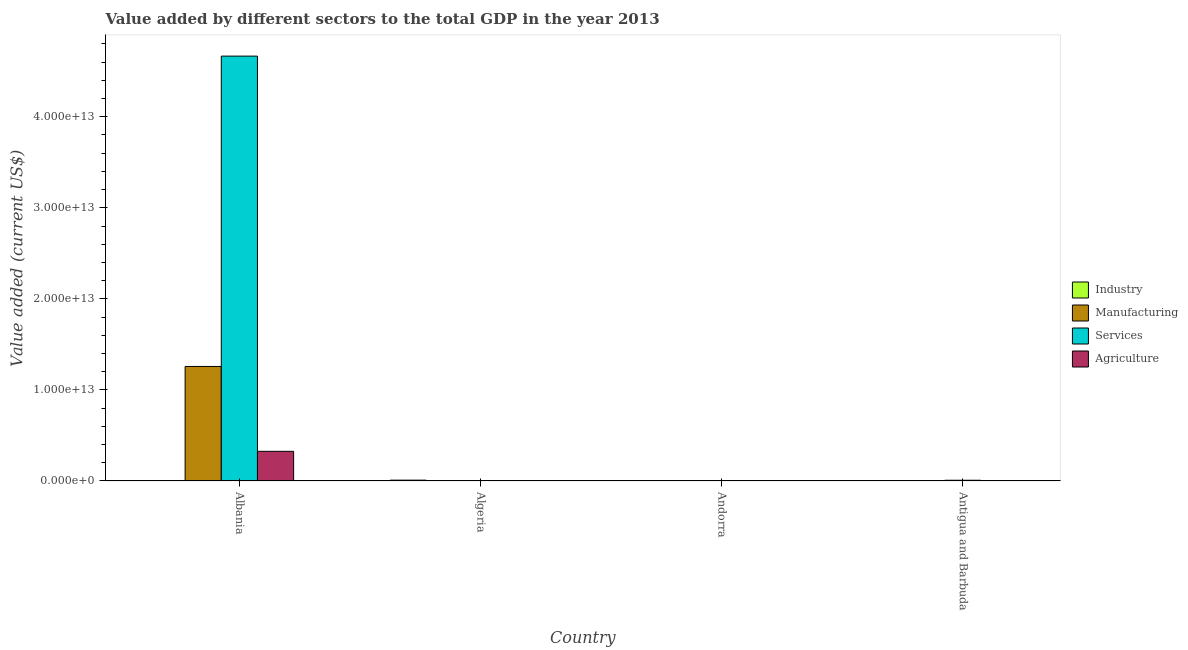How many different coloured bars are there?
Offer a very short reply. 4. Are the number of bars on each tick of the X-axis equal?
Give a very brief answer. Yes. How many bars are there on the 4th tick from the left?
Your answer should be very brief. 4. How many bars are there on the 3rd tick from the right?
Make the answer very short. 4. What is the label of the 4th group of bars from the left?
Offer a terse response. Antigua and Barbuda. In how many cases, is the number of bars for a given country not equal to the number of legend labels?
Keep it short and to the point. 0. What is the value added by services sector in Andorra?
Your answer should be compact. 5.70e+09. Across all countries, what is the maximum value added by agricultural sector?
Your answer should be compact. 3.26e+12. Across all countries, what is the minimum value added by services sector?
Provide a short and direct response. 5.70e+09. In which country was the value added by industrial sector maximum?
Ensure brevity in your answer.  Algeria. In which country was the value added by manufacturing sector minimum?
Give a very brief answer. Antigua and Barbuda. What is the total value added by agricultural sector in the graph?
Provide a succinct answer. 3.29e+12. What is the difference between the value added by agricultural sector in Algeria and that in Andorra?
Provide a short and direct response. 2.18e+09. What is the difference between the value added by industrial sector in Algeria and the value added by manufacturing sector in Andorra?
Ensure brevity in your answer.  9.21e+1. What is the average value added by agricultural sector per country?
Offer a very short reply. 8.22e+11. What is the difference between the value added by services sector and value added by industrial sector in Antigua and Barbuda?
Make the answer very short. 8.05e+1. What is the ratio of the value added by industrial sector in Algeria to that in Antigua and Barbuda?
Offer a terse response. 492.26. What is the difference between the highest and the second highest value added by manufacturing sector?
Provide a short and direct response. 1.26e+13. What is the difference between the highest and the lowest value added by industrial sector?
Make the answer very short. 9.26e+1. Is the sum of the value added by agricultural sector in Andorra and Antigua and Barbuda greater than the maximum value added by manufacturing sector across all countries?
Your answer should be compact. No. Is it the case that in every country, the sum of the value added by agricultural sector and value added by manufacturing sector is greater than the sum of value added by industrial sector and value added by services sector?
Offer a very short reply. No. What does the 4th bar from the left in Andorra represents?
Offer a very short reply. Agriculture. What does the 4th bar from the right in Algeria represents?
Ensure brevity in your answer.  Industry. Is it the case that in every country, the sum of the value added by industrial sector and value added by manufacturing sector is greater than the value added by services sector?
Ensure brevity in your answer.  No. How many countries are there in the graph?
Your answer should be very brief. 4. What is the difference between two consecutive major ticks on the Y-axis?
Offer a very short reply. 1.00e+13. Are the values on the major ticks of Y-axis written in scientific E-notation?
Keep it short and to the point. Yes. Does the graph contain grids?
Give a very brief answer. No. How many legend labels are there?
Keep it short and to the point. 4. What is the title of the graph?
Give a very brief answer. Value added by different sectors to the total GDP in the year 2013. What is the label or title of the X-axis?
Ensure brevity in your answer.  Country. What is the label or title of the Y-axis?
Your answer should be very brief. Value added (current US$). What is the Value added (current US$) in Industry in Albania?
Offer a very short reply. 2.94e+09. What is the Value added (current US$) in Manufacturing in Albania?
Your response must be concise. 1.26e+13. What is the Value added (current US$) in Services in Albania?
Make the answer very short. 4.67e+13. What is the Value added (current US$) in Agriculture in Albania?
Make the answer very short. 3.26e+12. What is the Value added (current US$) in Industry in Algeria?
Your answer should be compact. 9.27e+1. What is the Value added (current US$) of Manufacturing in Algeria?
Offer a terse response. 2.36e+09. What is the Value added (current US$) of Services in Algeria?
Your answer should be very brief. 1.08e+1. What is the Value added (current US$) of Agriculture in Algeria?
Provide a short and direct response. 4.69e+09. What is the Value added (current US$) of Industry in Andorra?
Your answer should be compact. 3.39e+08. What is the Value added (current US$) of Manufacturing in Andorra?
Your answer should be compact. 6.22e+08. What is the Value added (current US$) in Services in Andorra?
Make the answer very short. 5.70e+09. What is the Value added (current US$) in Agriculture in Andorra?
Your answer should be compact. 2.51e+09. What is the Value added (current US$) of Industry in Antigua and Barbuda?
Give a very brief answer. 1.88e+08. What is the Value added (current US$) of Manufacturing in Antigua and Barbuda?
Offer a very short reply. 1.03e+08. What is the Value added (current US$) of Services in Antigua and Barbuda?
Provide a short and direct response. 8.06e+1. What is the Value added (current US$) in Agriculture in Antigua and Barbuda?
Provide a short and direct response. 2.07e+1. Across all countries, what is the maximum Value added (current US$) in Industry?
Keep it short and to the point. 9.27e+1. Across all countries, what is the maximum Value added (current US$) in Manufacturing?
Your response must be concise. 1.26e+13. Across all countries, what is the maximum Value added (current US$) in Services?
Provide a succinct answer. 4.67e+13. Across all countries, what is the maximum Value added (current US$) in Agriculture?
Your answer should be very brief. 3.26e+12. Across all countries, what is the minimum Value added (current US$) of Industry?
Ensure brevity in your answer.  1.88e+08. Across all countries, what is the minimum Value added (current US$) of Manufacturing?
Give a very brief answer. 1.03e+08. Across all countries, what is the minimum Value added (current US$) in Services?
Offer a terse response. 5.70e+09. Across all countries, what is the minimum Value added (current US$) of Agriculture?
Your answer should be very brief. 2.51e+09. What is the total Value added (current US$) of Industry in the graph?
Keep it short and to the point. 9.62e+1. What is the total Value added (current US$) of Manufacturing in the graph?
Provide a short and direct response. 1.26e+13. What is the total Value added (current US$) of Services in the graph?
Your answer should be very brief. 4.68e+13. What is the total Value added (current US$) of Agriculture in the graph?
Your answer should be compact. 3.29e+12. What is the difference between the Value added (current US$) in Industry in Albania and that in Algeria?
Provide a short and direct response. -8.98e+1. What is the difference between the Value added (current US$) in Manufacturing in Albania and that in Algeria?
Your response must be concise. 1.26e+13. What is the difference between the Value added (current US$) in Services in Albania and that in Algeria?
Offer a terse response. 4.66e+13. What is the difference between the Value added (current US$) of Agriculture in Albania and that in Algeria?
Keep it short and to the point. 3.25e+12. What is the difference between the Value added (current US$) of Industry in Albania and that in Andorra?
Give a very brief answer. 2.60e+09. What is the difference between the Value added (current US$) in Manufacturing in Albania and that in Andorra?
Offer a terse response. 1.26e+13. What is the difference between the Value added (current US$) of Services in Albania and that in Andorra?
Your answer should be very brief. 4.67e+13. What is the difference between the Value added (current US$) of Agriculture in Albania and that in Andorra?
Give a very brief answer. 3.26e+12. What is the difference between the Value added (current US$) of Industry in Albania and that in Antigua and Barbuda?
Make the answer very short. 2.75e+09. What is the difference between the Value added (current US$) in Manufacturing in Albania and that in Antigua and Barbuda?
Make the answer very short. 1.26e+13. What is the difference between the Value added (current US$) of Services in Albania and that in Antigua and Barbuda?
Keep it short and to the point. 4.66e+13. What is the difference between the Value added (current US$) of Agriculture in Albania and that in Antigua and Barbuda?
Give a very brief answer. 3.24e+12. What is the difference between the Value added (current US$) of Industry in Algeria and that in Andorra?
Your response must be concise. 9.24e+1. What is the difference between the Value added (current US$) of Manufacturing in Algeria and that in Andorra?
Provide a succinct answer. 1.74e+09. What is the difference between the Value added (current US$) of Services in Algeria and that in Andorra?
Offer a terse response. 5.09e+09. What is the difference between the Value added (current US$) of Agriculture in Algeria and that in Andorra?
Ensure brevity in your answer.  2.18e+09. What is the difference between the Value added (current US$) in Industry in Algeria and that in Antigua and Barbuda?
Provide a short and direct response. 9.26e+1. What is the difference between the Value added (current US$) in Manufacturing in Algeria and that in Antigua and Barbuda?
Your answer should be compact. 2.26e+09. What is the difference between the Value added (current US$) of Services in Algeria and that in Antigua and Barbuda?
Keep it short and to the point. -6.99e+1. What is the difference between the Value added (current US$) in Agriculture in Algeria and that in Antigua and Barbuda?
Offer a very short reply. -1.60e+1. What is the difference between the Value added (current US$) of Industry in Andorra and that in Antigua and Barbuda?
Keep it short and to the point. 1.50e+08. What is the difference between the Value added (current US$) in Manufacturing in Andorra and that in Antigua and Barbuda?
Give a very brief answer. 5.19e+08. What is the difference between the Value added (current US$) of Services in Andorra and that in Antigua and Barbuda?
Give a very brief answer. -7.49e+1. What is the difference between the Value added (current US$) in Agriculture in Andorra and that in Antigua and Barbuda?
Provide a succinct answer. -1.82e+1. What is the difference between the Value added (current US$) of Industry in Albania and the Value added (current US$) of Manufacturing in Algeria?
Make the answer very short. 5.79e+08. What is the difference between the Value added (current US$) of Industry in Albania and the Value added (current US$) of Services in Algeria?
Provide a succinct answer. -7.85e+09. What is the difference between the Value added (current US$) of Industry in Albania and the Value added (current US$) of Agriculture in Algeria?
Your answer should be compact. -1.75e+09. What is the difference between the Value added (current US$) in Manufacturing in Albania and the Value added (current US$) in Services in Algeria?
Offer a terse response. 1.26e+13. What is the difference between the Value added (current US$) of Manufacturing in Albania and the Value added (current US$) of Agriculture in Algeria?
Your answer should be very brief. 1.26e+13. What is the difference between the Value added (current US$) in Services in Albania and the Value added (current US$) in Agriculture in Algeria?
Your answer should be very brief. 4.67e+13. What is the difference between the Value added (current US$) in Industry in Albania and the Value added (current US$) in Manufacturing in Andorra?
Make the answer very short. 2.32e+09. What is the difference between the Value added (current US$) in Industry in Albania and the Value added (current US$) in Services in Andorra?
Give a very brief answer. -2.76e+09. What is the difference between the Value added (current US$) of Industry in Albania and the Value added (current US$) of Agriculture in Andorra?
Your response must be concise. 4.31e+08. What is the difference between the Value added (current US$) of Manufacturing in Albania and the Value added (current US$) of Services in Andorra?
Keep it short and to the point. 1.26e+13. What is the difference between the Value added (current US$) in Manufacturing in Albania and the Value added (current US$) in Agriculture in Andorra?
Provide a short and direct response. 1.26e+13. What is the difference between the Value added (current US$) of Services in Albania and the Value added (current US$) of Agriculture in Andorra?
Provide a short and direct response. 4.67e+13. What is the difference between the Value added (current US$) in Industry in Albania and the Value added (current US$) in Manufacturing in Antigua and Barbuda?
Your response must be concise. 2.84e+09. What is the difference between the Value added (current US$) in Industry in Albania and the Value added (current US$) in Services in Antigua and Barbuda?
Your answer should be compact. -7.77e+1. What is the difference between the Value added (current US$) of Industry in Albania and the Value added (current US$) of Agriculture in Antigua and Barbuda?
Offer a very short reply. -1.77e+1. What is the difference between the Value added (current US$) of Manufacturing in Albania and the Value added (current US$) of Services in Antigua and Barbuda?
Make the answer very short. 1.25e+13. What is the difference between the Value added (current US$) of Manufacturing in Albania and the Value added (current US$) of Agriculture in Antigua and Barbuda?
Your answer should be compact. 1.26e+13. What is the difference between the Value added (current US$) of Services in Albania and the Value added (current US$) of Agriculture in Antigua and Barbuda?
Your response must be concise. 4.66e+13. What is the difference between the Value added (current US$) in Industry in Algeria and the Value added (current US$) in Manufacturing in Andorra?
Make the answer very short. 9.21e+1. What is the difference between the Value added (current US$) of Industry in Algeria and the Value added (current US$) of Services in Andorra?
Keep it short and to the point. 8.70e+1. What is the difference between the Value added (current US$) of Industry in Algeria and the Value added (current US$) of Agriculture in Andorra?
Keep it short and to the point. 9.02e+1. What is the difference between the Value added (current US$) of Manufacturing in Algeria and the Value added (current US$) of Services in Andorra?
Provide a succinct answer. -3.34e+09. What is the difference between the Value added (current US$) in Manufacturing in Algeria and the Value added (current US$) in Agriculture in Andorra?
Offer a terse response. -1.48e+08. What is the difference between the Value added (current US$) of Services in Algeria and the Value added (current US$) of Agriculture in Andorra?
Provide a short and direct response. 8.28e+09. What is the difference between the Value added (current US$) in Industry in Algeria and the Value added (current US$) in Manufacturing in Antigua and Barbuda?
Ensure brevity in your answer.  9.26e+1. What is the difference between the Value added (current US$) of Industry in Algeria and the Value added (current US$) of Services in Antigua and Barbuda?
Give a very brief answer. 1.21e+1. What is the difference between the Value added (current US$) in Industry in Algeria and the Value added (current US$) in Agriculture in Antigua and Barbuda?
Your answer should be compact. 7.21e+1. What is the difference between the Value added (current US$) of Manufacturing in Algeria and the Value added (current US$) of Services in Antigua and Barbuda?
Ensure brevity in your answer.  -7.83e+1. What is the difference between the Value added (current US$) in Manufacturing in Algeria and the Value added (current US$) in Agriculture in Antigua and Barbuda?
Offer a very short reply. -1.83e+1. What is the difference between the Value added (current US$) of Services in Algeria and the Value added (current US$) of Agriculture in Antigua and Barbuda?
Make the answer very short. -9.87e+09. What is the difference between the Value added (current US$) in Industry in Andorra and the Value added (current US$) in Manufacturing in Antigua and Barbuda?
Your answer should be compact. 2.36e+08. What is the difference between the Value added (current US$) in Industry in Andorra and the Value added (current US$) in Services in Antigua and Barbuda?
Make the answer very short. -8.03e+1. What is the difference between the Value added (current US$) in Industry in Andorra and the Value added (current US$) in Agriculture in Antigua and Barbuda?
Provide a succinct answer. -2.03e+1. What is the difference between the Value added (current US$) of Manufacturing in Andorra and the Value added (current US$) of Services in Antigua and Barbuda?
Your response must be concise. -8.00e+1. What is the difference between the Value added (current US$) in Manufacturing in Andorra and the Value added (current US$) in Agriculture in Antigua and Barbuda?
Your answer should be very brief. -2.00e+1. What is the difference between the Value added (current US$) in Services in Andorra and the Value added (current US$) in Agriculture in Antigua and Barbuda?
Provide a short and direct response. -1.50e+1. What is the average Value added (current US$) of Industry per country?
Ensure brevity in your answer.  2.41e+1. What is the average Value added (current US$) of Manufacturing per country?
Your answer should be compact. 3.15e+12. What is the average Value added (current US$) of Services per country?
Give a very brief answer. 1.17e+13. What is the average Value added (current US$) of Agriculture per country?
Your answer should be very brief. 8.22e+11. What is the difference between the Value added (current US$) of Industry and Value added (current US$) of Manufacturing in Albania?
Provide a succinct answer. -1.26e+13. What is the difference between the Value added (current US$) of Industry and Value added (current US$) of Services in Albania?
Offer a terse response. -4.67e+13. What is the difference between the Value added (current US$) in Industry and Value added (current US$) in Agriculture in Albania?
Provide a short and direct response. -3.26e+12. What is the difference between the Value added (current US$) in Manufacturing and Value added (current US$) in Services in Albania?
Ensure brevity in your answer.  -3.41e+13. What is the difference between the Value added (current US$) in Manufacturing and Value added (current US$) in Agriculture in Albania?
Your answer should be very brief. 9.32e+12. What is the difference between the Value added (current US$) in Services and Value added (current US$) in Agriculture in Albania?
Your response must be concise. 4.34e+13. What is the difference between the Value added (current US$) in Industry and Value added (current US$) in Manufacturing in Algeria?
Provide a succinct answer. 9.04e+1. What is the difference between the Value added (current US$) in Industry and Value added (current US$) in Services in Algeria?
Offer a terse response. 8.20e+1. What is the difference between the Value added (current US$) of Industry and Value added (current US$) of Agriculture in Algeria?
Keep it short and to the point. 8.81e+1. What is the difference between the Value added (current US$) of Manufacturing and Value added (current US$) of Services in Algeria?
Keep it short and to the point. -8.43e+09. What is the difference between the Value added (current US$) of Manufacturing and Value added (current US$) of Agriculture in Algeria?
Give a very brief answer. -2.33e+09. What is the difference between the Value added (current US$) in Services and Value added (current US$) in Agriculture in Algeria?
Provide a short and direct response. 6.10e+09. What is the difference between the Value added (current US$) in Industry and Value added (current US$) in Manufacturing in Andorra?
Make the answer very short. -2.83e+08. What is the difference between the Value added (current US$) of Industry and Value added (current US$) of Services in Andorra?
Your answer should be compact. -5.36e+09. What is the difference between the Value added (current US$) in Industry and Value added (current US$) in Agriculture in Andorra?
Provide a succinct answer. -2.17e+09. What is the difference between the Value added (current US$) in Manufacturing and Value added (current US$) in Services in Andorra?
Give a very brief answer. -5.08e+09. What is the difference between the Value added (current US$) of Manufacturing and Value added (current US$) of Agriculture in Andorra?
Provide a succinct answer. -1.89e+09. What is the difference between the Value added (current US$) in Services and Value added (current US$) in Agriculture in Andorra?
Your response must be concise. 3.19e+09. What is the difference between the Value added (current US$) of Industry and Value added (current US$) of Manufacturing in Antigua and Barbuda?
Your response must be concise. 8.56e+07. What is the difference between the Value added (current US$) of Industry and Value added (current US$) of Services in Antigua and Barbuda?
Your answer should be very brief. -8.05e+1. What is the difference between the Value added (current US$) in Industry and Value added (current US$) in Agriculture in Antigua and Barbuda?
Your answer should be very brief. -2.05e+1. What is the difference between the Value added (current US$) of Manufacturing and Value added (current US$) of Services in Antigua and Barbuda?
Keep it short and to the point. -8.05e+1. What is the difference between the Value added (current US$) of Manufacturing and Value added (current US$) of Agriculture in Antigua and Barbuda?
Offer a terse response. -2.06e+1. What is the difference between the Value added (current US$) in Services and Value added (current US$) in Agriculture in Antigua and Barbuda?
Your answer should be very brief. 6.00e+1. What is the ratio of the Value added (current US$) of Industry in Albania to that in Algeria?
Your response must be concise. 0.03. What is the ratio of the Value added (current US$) in Manufacturing in Albania to that in Algeria?
Offer a very short reply. 5326.69. What is the ratio of the Value added (current US$) in Services in Albania to that in Algeria?
Provide a short and direct response. 4325.08. What is the ratio of the Value added (current US$) in Agriculture in Albania to that in Algeria?
Offer a very short reply. 694.88. What is the ratio of the Value added (current US$) of Industry in Albania to that in Andorra?
Give a very brief answer. 8.69. What is the ratio of the Value added (current US$) of Manufacturing in Albania to that in Andorra?
Your response must be concise. 2.02e+04. What is the ratio of the Value added (current US$) in Services in Albania to that in Andorra?
Your answer should be compact. 8184.35. What is the ratio of the Value added (current US$) of Agriculture in Albania to that in Andorra?
Ensure brevity in your answer.  1298.84. What is the ratio of the Value added (current US$) in Industry in Albania to that in Antigua and Barbuda?
Keep it short and to the point. 15.61. What is the ratio of the Value added (current US$) of Manufacturing in Albania to that in Antigua and Barbuda?
Provide a short and direct response. 1.22e+05. What is the ratio of the Value added (current US$) of Services in Albania to that in Antigua and Barbuda?
Provide a short and direct response. 578.57. What is the ratio of the Value added (current US$) in Agriculture in Albania to that in Antigua and Barbuda?
Your response must be concise. 157.72. What is the ratio of the Value added (current US$) in Industry in Algeria to that in Andorra?
Your answer should be very brief. 273.95. What is the ratio of the Value added (current US$) in Manufacturing in Algeria to that in Andorra?
Keep it short and to the point. 3.8. What is the ratio of the Value added (current US$) in Services in Algeria to that in Andorra?
Ensure brevity in your answer.  1.89. What is the ratio of the Value added (current US$) in Agriculture in Algeria to that in Andorra?
Your answer should be compact. 1.87. What is the ratio of the Value added (current US$) in Industry in Algeria to that in Antigua and Barbuda?
Your answer should be compact. 492.26. What is the ratio of the Value added (current US$) of Manufacturing in Algeria to that in Antigua and Barbuda?
Your answer should be very brief. 22.97. What is the ratio of the Value added (current US$) of Services in Algeria to that in Antigua and Barbuda?
Offer a very short reply. 0.13. What is the ratio of the Value added (current US$) of Agriculture in Algeria to that in Antigua and Barbuda?
Provide a short and direct response. 0.23. What is the ratio of the Value added (current US$) in Industry in Andorra to that in Antigua and Barbuda?
Provide a succinct answer. 1.8. What is the ratio of the Value added (current US$) in Manufacturing in Andorra to that in Antigua and Barbuda?
Keep it short and to the point. 6.05. What is the ratio of the Value added (current US$) of Services in Andorra to that in Antigua and Barbuda?
Your answer should be very brief. 0.07. What is the ratio of the Value added (current US$) in Agriculture in Andorra to that in Antigua and Barbuda?
Provide a succinct answer. 0.12. What is the difference between the highest and the second highest Value added (current US$) in Industry?
Provide a short and direct response. 8.98e+1. What is the difference between the highest and the second highest Value added (current US$) in Manufacturing?
Your answer should be compact. 1.26e+13. What is the difference between the highest and the second highest Value added (current US$) of Services?
Keep it short and to the point. 4.66e+13. What is the difference between the highest and the second highest Value added (current US$) of Agriculture?
Make the answer very short. 3.24e+12. What is the difference between the highest and the lowest Value added (current US$) in Industry?
Keep it short and to the point. 9.26e+1. What is the difference between the highest and the lowest Value added (current US$) of Manufacturing?
Your answer should be compact. 1.26e+13. What is the difference between the highest and the lowest Value added (current US$) in Services?
Provide a succinct answer. 4.67e+13. What is the difference between the highest and the lowest Value added (current US$) of Agriculture?
Your answer should be very brief. 3.26e+12. 